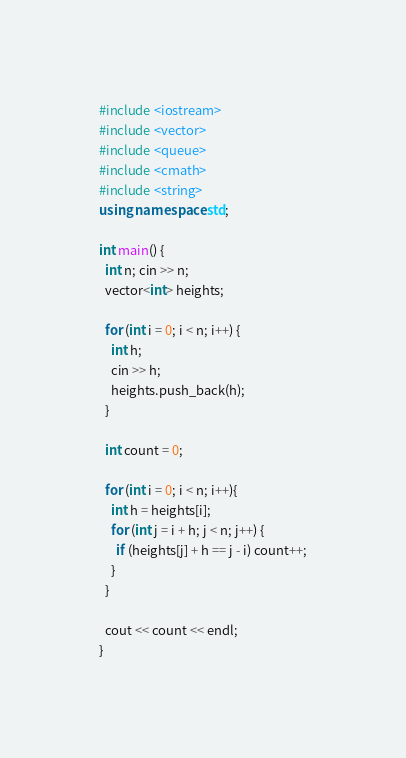Convert code to text. <code><loc_0><loc_0><loc_500><loc_500><_C++_>#include <iostream>
#include <vector>
#include <queue>
#include <cmath>
#include <string>
using namespace std;

int main() {
  int n; cin >> n;
  vector<int> heights;

  for (int i = 0; i < n; i++) {
    int h;
    cin >> h;
    heights.push_back(h);
  }

  int count = 0;

  for (int i = 0; i < n; i++){
    int h = heights[i];
    for (int j = i + h; j < n; j++) {
      if (heights[j] + h == j - i) count++;
    }
  }

  cout << count << endl;
}</code> 